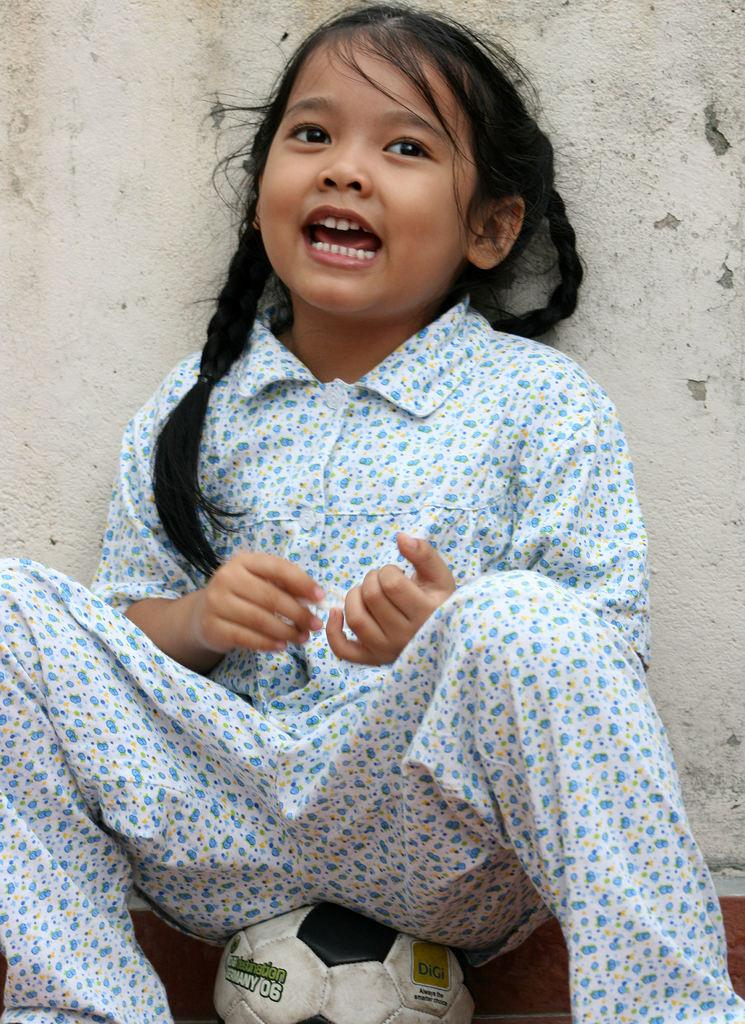Who is the main subject in the image? There is a girl in the image. What is the girl doing in the image? The girl is sitting on a ball. What can be seen in the background of the image? There is a wall in the background of the image. What type of breakfast is the girl eating in the image? There is no breakfast present in the image; the girl is sitting on a ball. How many chickens are visible in the image? There are no chickens present in the image. 